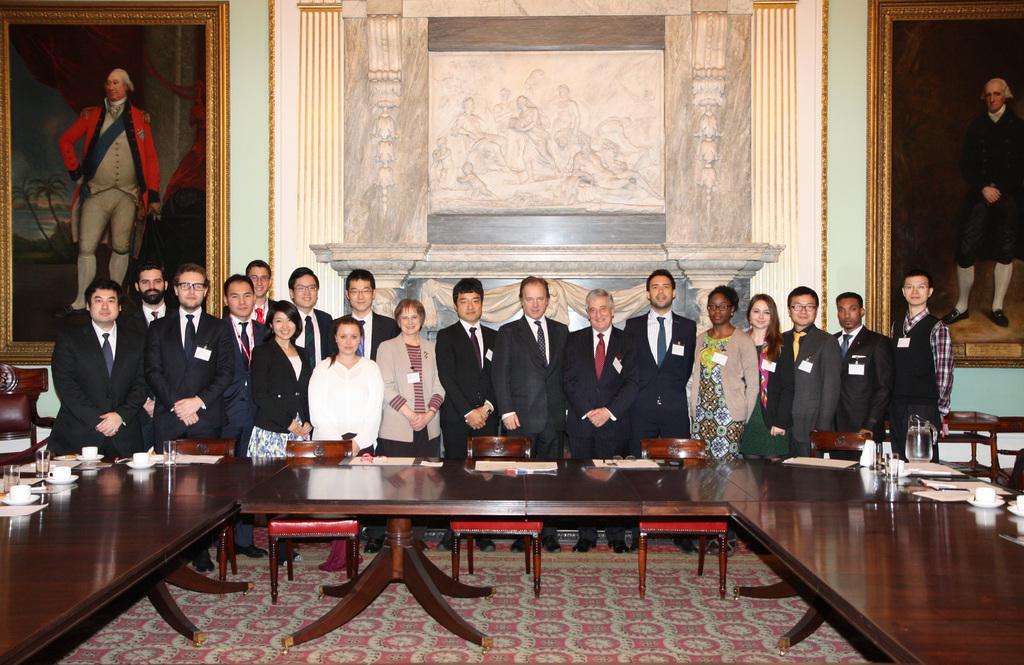Describe this image in one or two sentences. A group of persons are standing together behind them there are big photographs and the wall. 